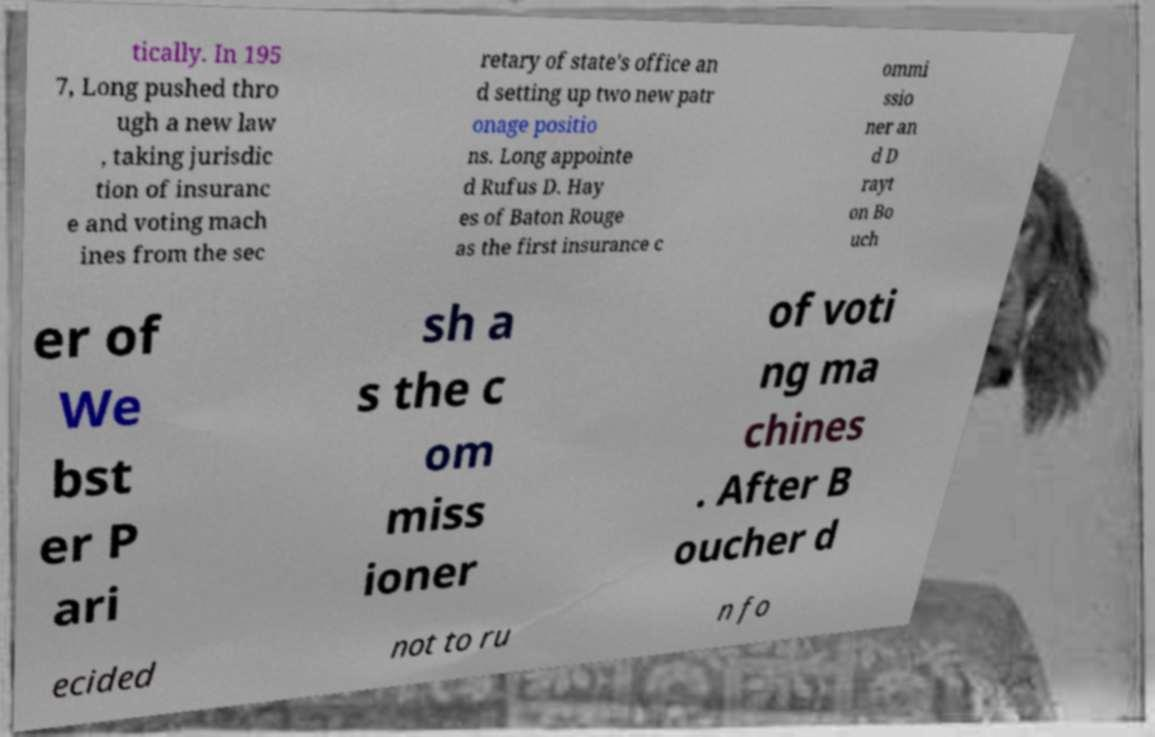I need the written content from this picture converted into text. Can you do that? tically. In 195 7, Long pushed thro ugh a new law , taking jurisdic tion of insuranc e and voting mach ines from the sec retary of state's office an d setting up two new patr onage positio ns. Long appointe d Rufus D. Hay es of Baton Rouge as the first insurance c ommi ssio ner an d D rayt on Bo uch er of We bst er P ari sh a s the c om miss ioner of voti ng ma chines . After B oucher d ecided not to ru n fo 